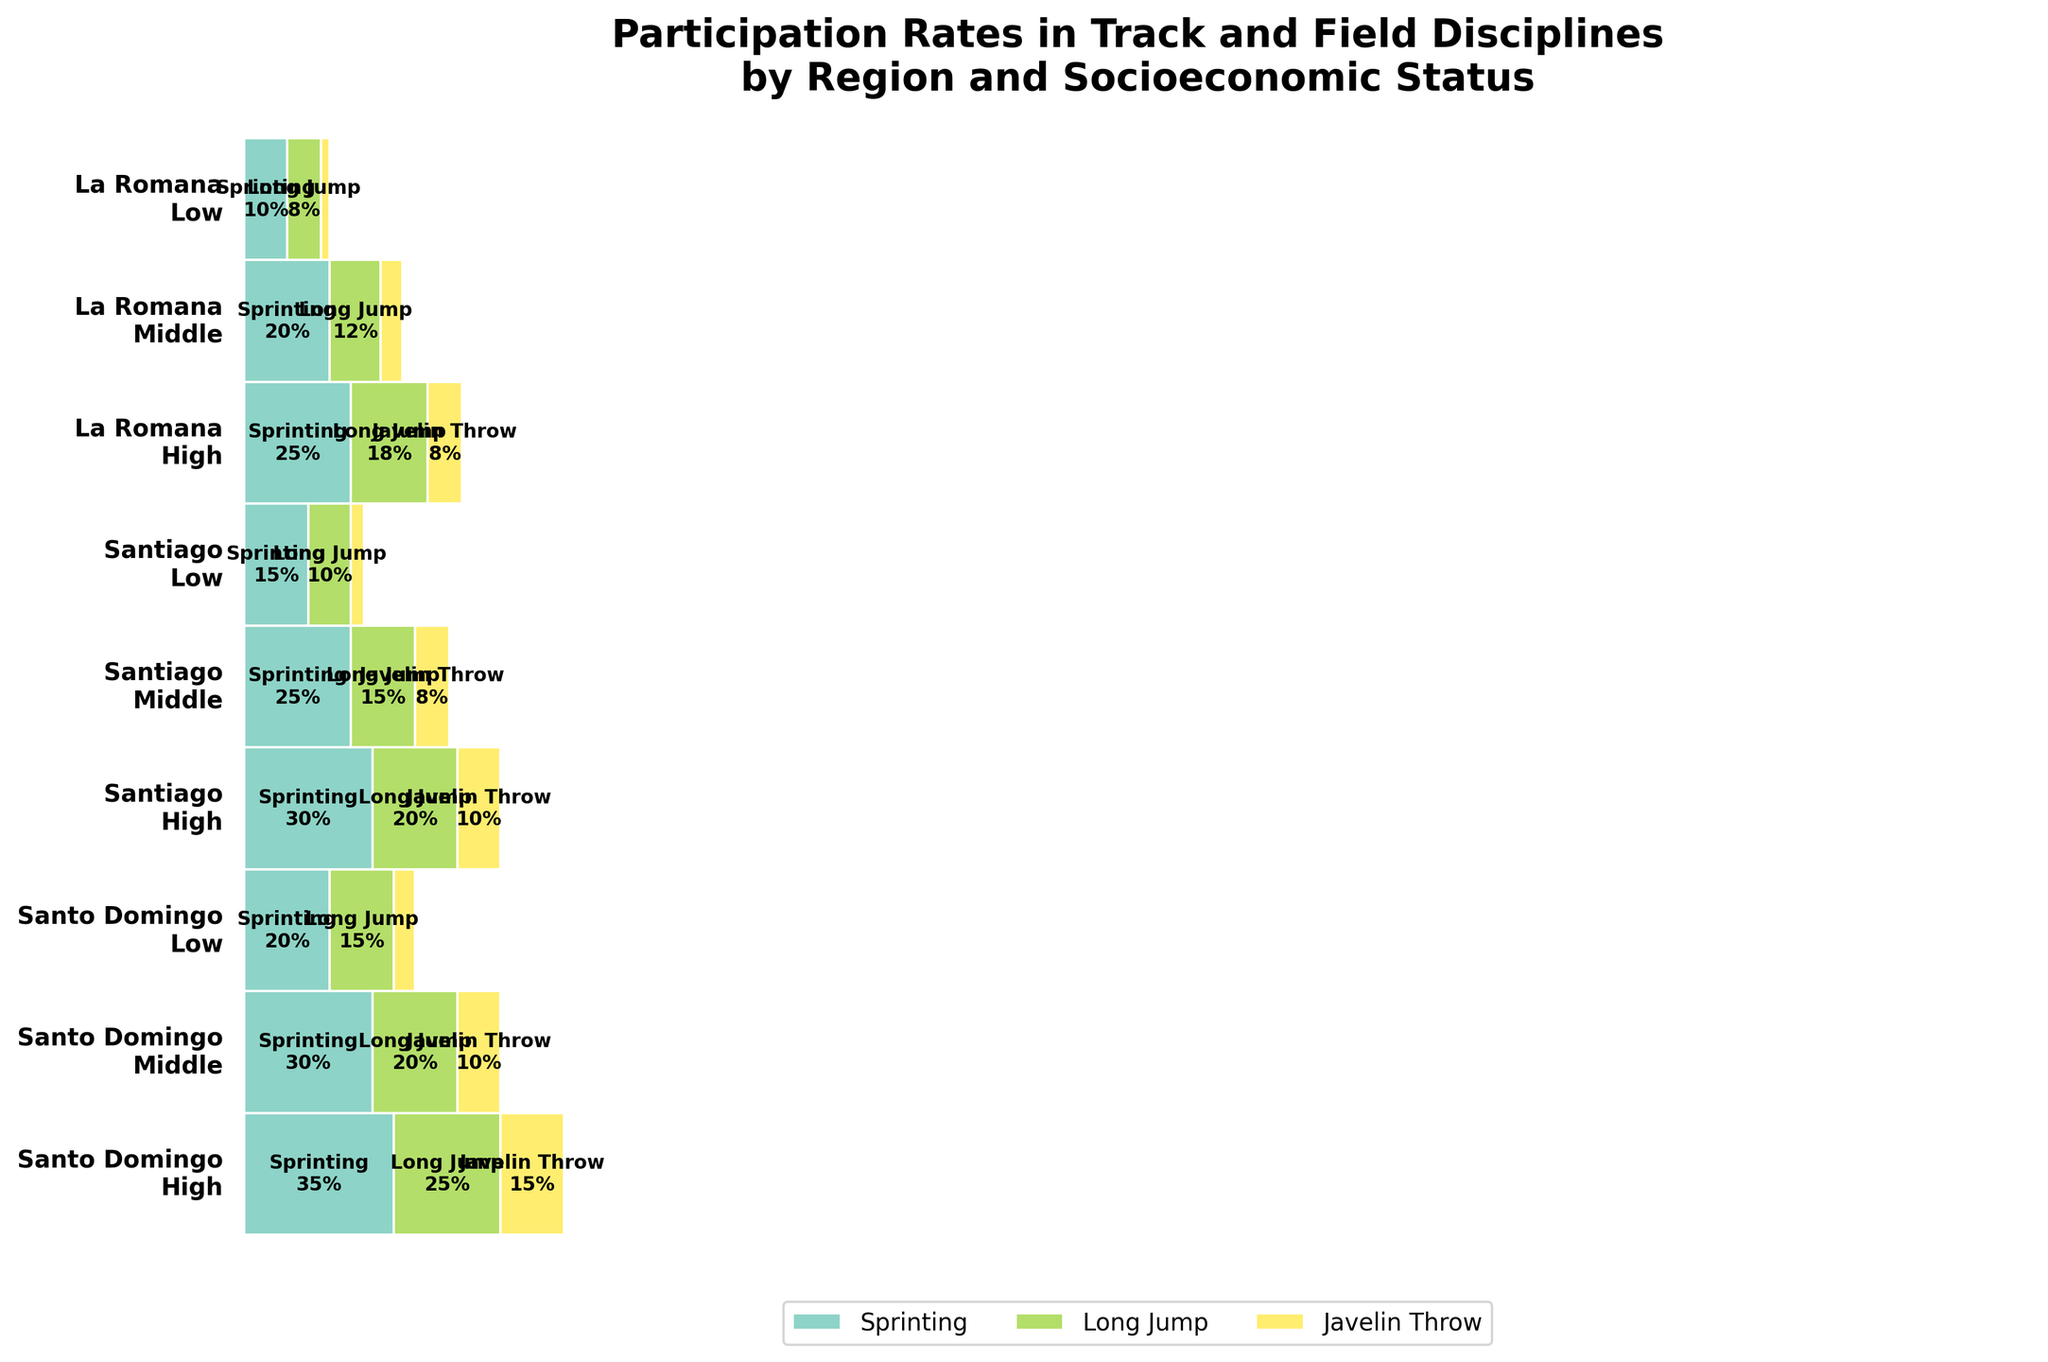What is the title of the plot? The title is usually found at the very top of the plot. It provides a summary of what the plot is about.
Answer: Participation Rates in Track and Field Disciplines by Region and Socioeconomic Status Which discipline has the highest participation rate in Santo Domingo among high socioeconomic status individuals? Look at the sections for Santo Domingo labeled "High" and find the discipline with the largest width.
Answer: Sprinting What is the participation rate for Javelin Throw in Santiago among individuals from low socioeconomic status? Locate the section for Santiago labeled "Low" and find the participation rate for the Javelin Throw.
Answer: 3% Compare the participation rates for Long Jump among middle socioeconomic status individuals in Santo Domingo and Santiago. Which is higher? Find the sections for middle socioeconomic status in both Santo Domingo and Santiago, and then compare the widths for Long Jump.
Answer: Santo Domingo How does the participation rate in Sprinting for high socioeconomic status individuals in Santiago compare to those in La Romana? Locate the sections for high socioeconomic status in Santiago and La Romana, and compare the widths for Sprinting.
Answer: Higher in Santiago What is the total participation rate for all disciplines in La Romana among low socioeconomic status individuals? Sum the widths of all disciplines in the La Romana section labeled "Low".
Answer: 20% Is the participation rate for Long Jump among high socioeconomic status individuals in Santo Domingo more than double that of low socioeconomic status individuals in the same region? Compare the Long Jump participation rates between high and low socioeconomic statuses in Santo Domingo to see if one is more than double the other.
Answer: Yes Which socioeconomic status has the lowest participation rate in Javelin Throw in Santiago? Locate Javelin Throw participation rates in Santiago for all socioeconomic statuses and identify the one with the smallest width.
Answer: Low How many disciplines are depicted in the plot? Count the different unique colors, which represent the disciplines in the legend.
Answer: 3 disciplines What is the participation rate difference for Sprinting between middle and low socioeconomic statuses in Santiago? Identify the participation rates for Sprinting among middle and low socioeconomic statuses in Santiago and subtract the smaller from the larger.
Answer: 10% 